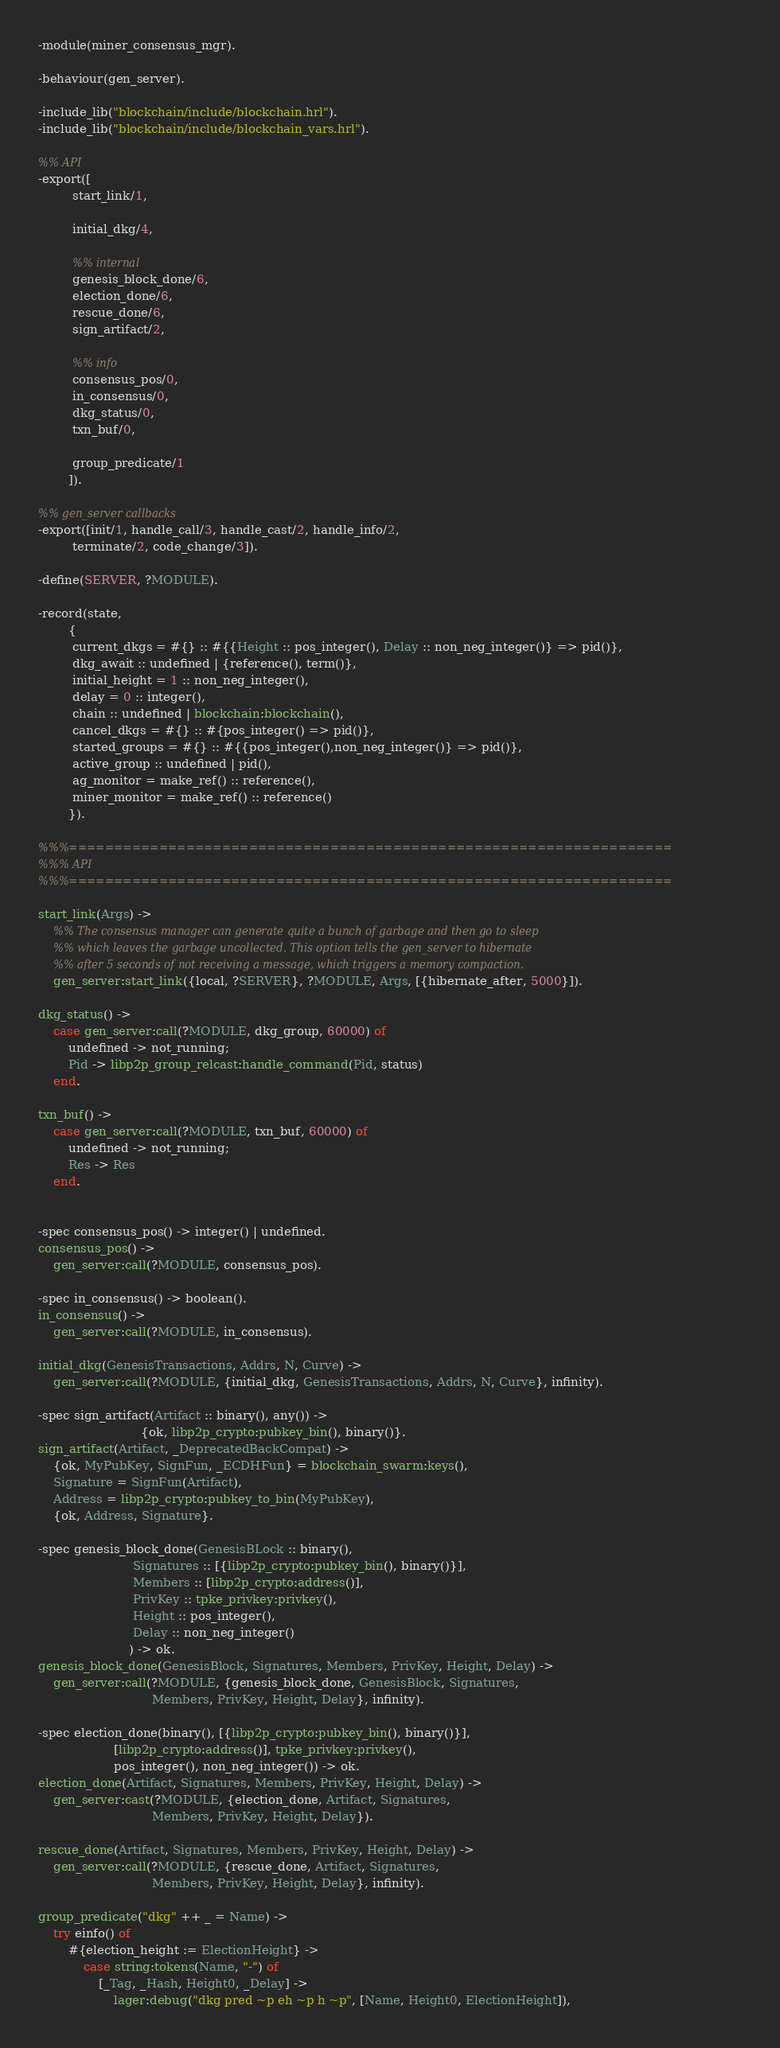<code> <loc_0><loc_0><loc_500><loc_500><_Erlang_>-module(miner_consensus_mgr).

-behaviour(gen_server).

-include_lib("blockchain/include/blockchain.hrl").
-include_lib("blockchain/include/blockchain_vars.hrl").

%% API
-export([
         start_link/1,

         initial_dkg/4,

         %% internal
         genesis_block_done/6,
         election_done/6,
         rescue_done/6,
         sign_artifact/2,

         %% info
         consensus_pos/0,
         in_consensus/0,
         dkg_status/0,
         txn_buf/0,

         group_predicate/1
        ]).

%% gen_server callbacks
-export([init/1, handle_call/3, handle_cast/2, handle_info/2,
         terminate/2, code_change/3]).

-define(SERVER, ?MODULE).

-record(state,
        {
         current_dkgs = #{} :: #{{Height :: pos_integer(), Delay :: non_neg_integer()} => pid()},
         dkg_await :: undefined | {reference(), term()},
         initial_height = 1 :: non_neg_integer(),
         delay = 0 :: integer(),
         chain :: undefined | blockchain:blockchain(),
         cancel_dkgs = #{} :: #{pos_integer() => pid()},
         started_groups = #{} :: #{{pos_integer(),non_neg_integer()} => pid()},
         active_group :: undefined | pid(),
         ag_monitor = make_ref() :: reference(),
         miner_monitor = make_ref() :: reference()
        }).

%%%===================================================================
%%% API
%%%===================================================================

start_link(Args) ->
    %% The consensus manager can generate quite a bunch of garbage and then go to sleep
    %% which leaves the garbage uncollected. This option tells the gen_server to hibernate
    %% after 5 seconds of not receiving a message, which triggers a memory compaction.
    gen_server:start_link({local, ?SERVER}, ?MODULE, Args, [{hibernate_after, 5000}]).

dkg_status() ->
    case gen_server:call(?MODULE, dkg_group, 60000) of
        undefined -> not_running;
        Pid -> libp2p_group_relcast:handle_command(Pid, status)
    end.

txn_buf() ->
    case gen_server:call(?MODULE, txn_buf, 60000) of
        undefined -> not_running;
        Res -> Res
    end.


-spec consensus_pos() -> integer() | undefined.
consensus_pos() ->
    gen_server:call(?MODULE, consensus_pos).

-spec in_consensus() -> boolean().
in_consensus() ->
    gen_server:call(?MODULE, in_consensus).

initial_dkg(GenesisTransactions, Addrs, N, Curve) ->
    gen_server:call(?MODULE, {initial_dkg, GenesisTransactions, Addrs, N, Curve}, infinity).

-spec sign_artifact(Artifact :: binary(), any()) ->
                           {ok, libp2p_crypto:pubkey_bin(), binary()}.
sign_artifact(Artifact, _DeprecatedBackCompat) ->
    {ok, MyPubKey, SignFun, _ECDHFun} = blockchain_swarm:keys(),
    Signature = SignFun(Artifact),
    Address = libp2p_crypto:pubkey_to_bin(MyPubKey),
    {ok, Address, Signature}.

-spec genesis_block_done(GenesisBLock :: binary(),
                         Signatures :: [{libp2p_crypto:pubkey_bin(), binary()}],
                         Members :: [libp2p_crypto:address()],
                         PrivKey :: tpke_privkey:privkey(),
                         Height :: pos_integer(),
                         Delay :: non_neg_integer()
                        ) -> ok.
genesis_block_done(GenesisBlock, Signatures, Members, PrivKey, Height, Delay) ->
    gen_server:call(?MODULE, {genesis_block_done, GenesisBlock, Signatures,
                              Members, PrivKey, Height, Delay}, infinity).

-spec election_done(binary(), [{libp2p_crypto:pubkey_bin(), binary()}],
                    [libp2p_crypto:address()], tpke_privkey:privkey(),
                    pos_integer(), non_neg_integer()) -> ok.
election_done(Artifact, Signatures, Members, PrivKey, Height, Delay) ->
    gen_server:cast(?MODULE, {election_done, Artifact, Signatures,
                              Members, PrivKey, Height, Delay}).

rescue_done(Artifact, Signatures, Members, PrivKey, Height, Delay) ->
    gen_server:call(?MODULE, {rescue_done, Artifact, Signatures,
                              Members, PrivKey, Height, Delay}, infinity).

group_predicate("dkg" ++ _ = Name) ->
    try einfo() of
        #{election_height := ElectionHeight} ->
            case string:tokens(Name, "-") of
                [_Tag, _Hash, Height0, _Delay] ->
                    lager:debug("dkg pred ~p eh ~p h ~p", [Name, Height0, ElectionHeight]),</code> 